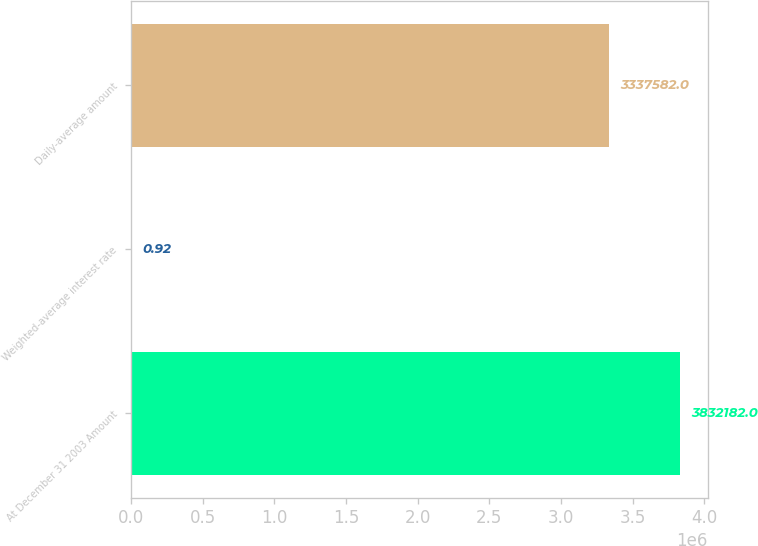Convert chart. <chart><loc_0><loc_0><loc_500><loc_500><bar_chart><fcel>At December 31 2003 Amount<fcel>Weighted-average interest rate<fcel>Daily-average amount<nl><fcel>3.83218e+06<fcel>0.92<fcel>3.33758e+06<nl></chart> 